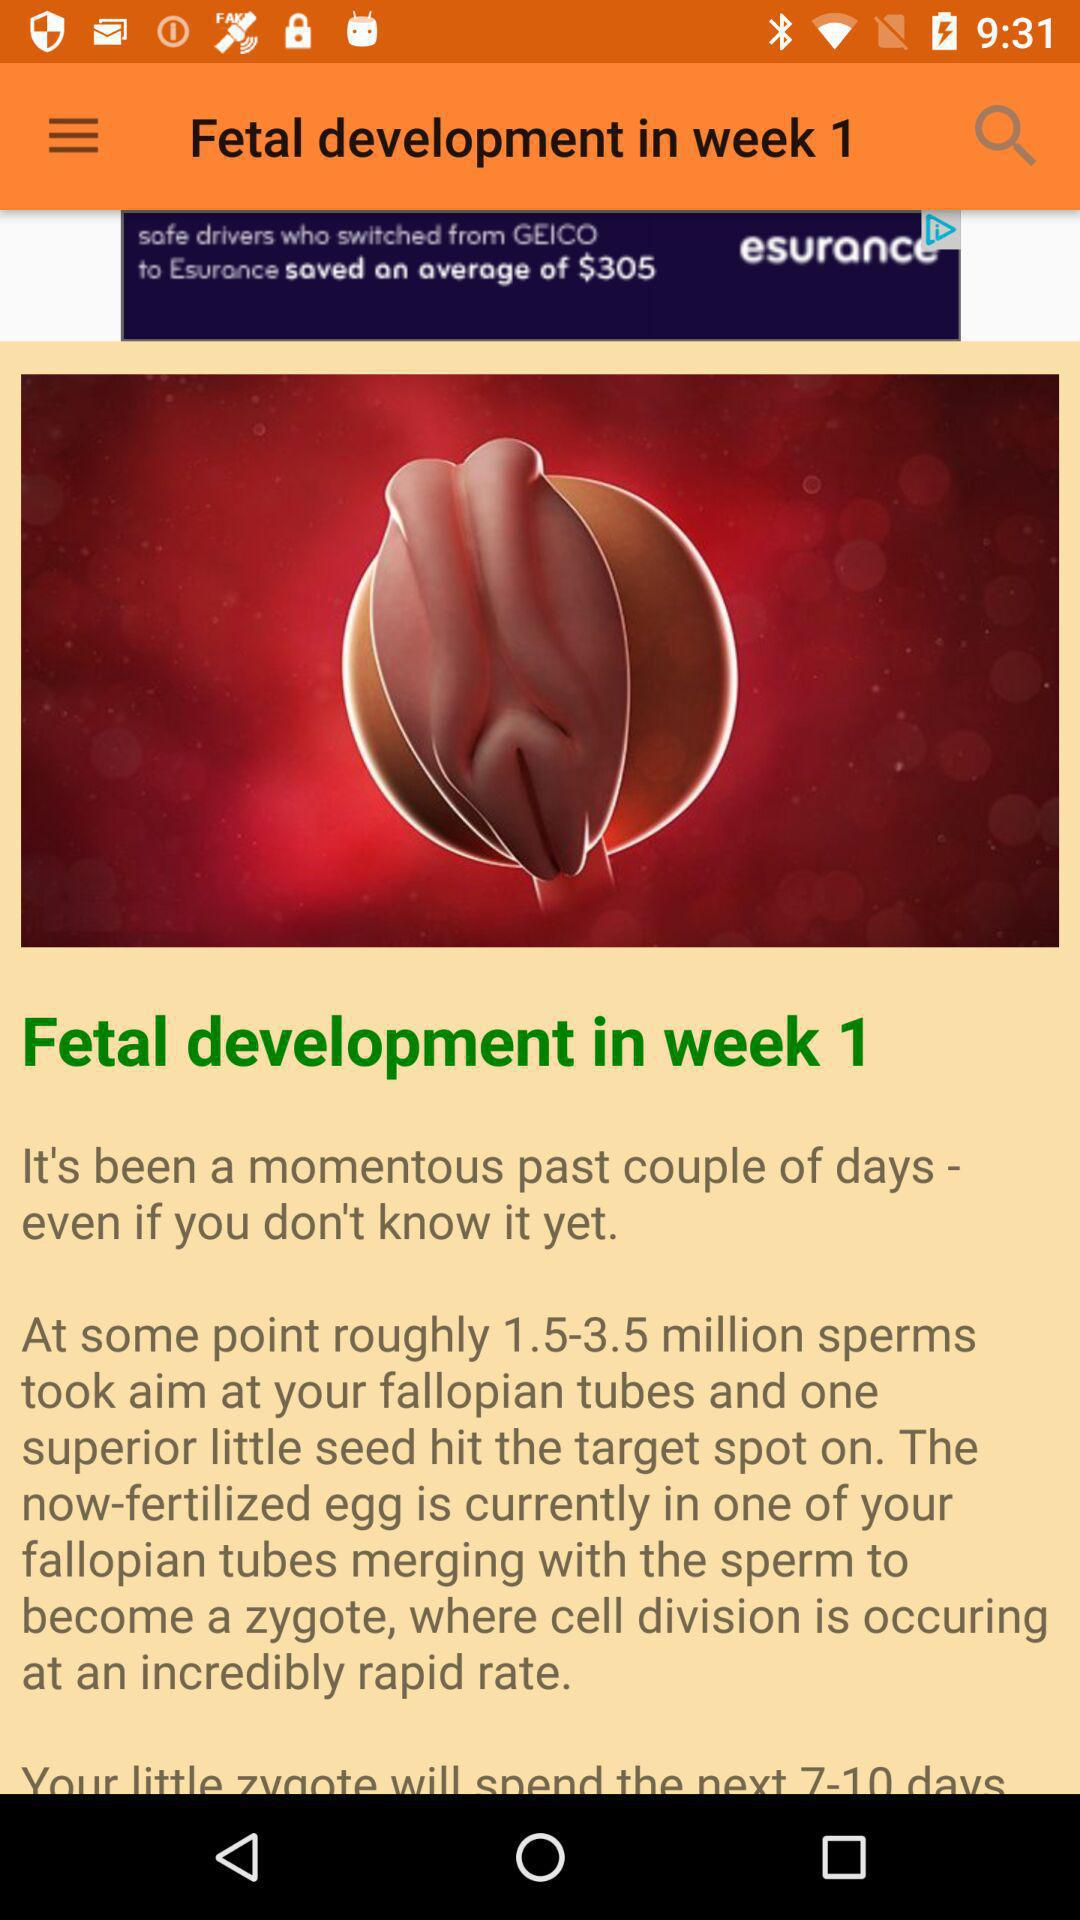What happens when a fertilized egg merges with sperm? A fertilized egg merges with sperm to become a zygote, where cell division is occurring at an incredibly rapid rate. 